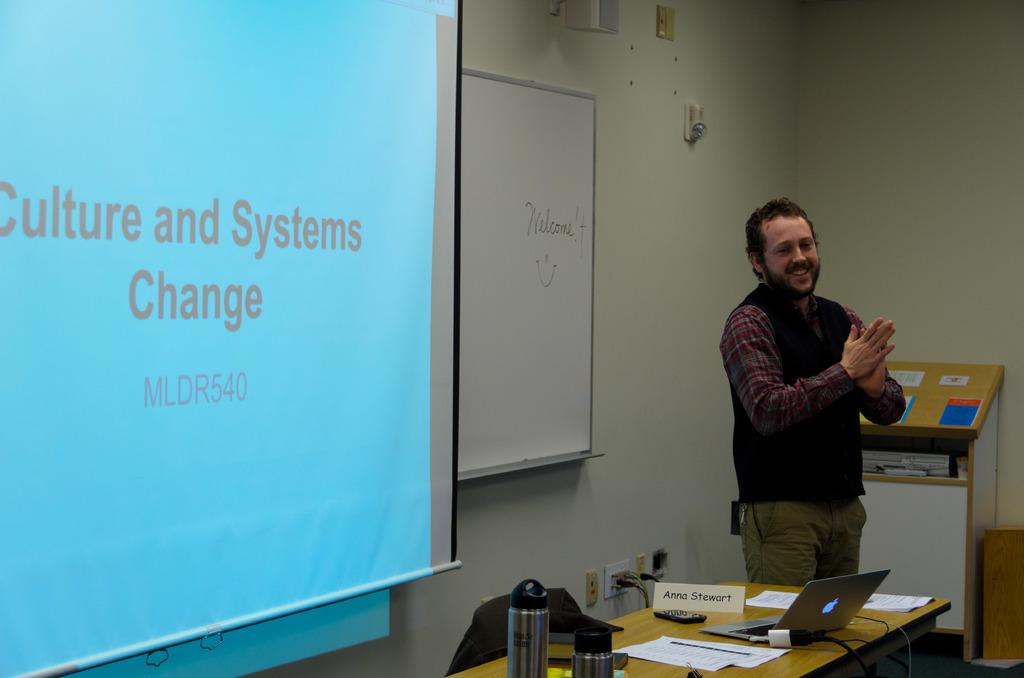<image>
Write a terse but informative summary of the picture. A man is giving a lecture on culture and system change. 